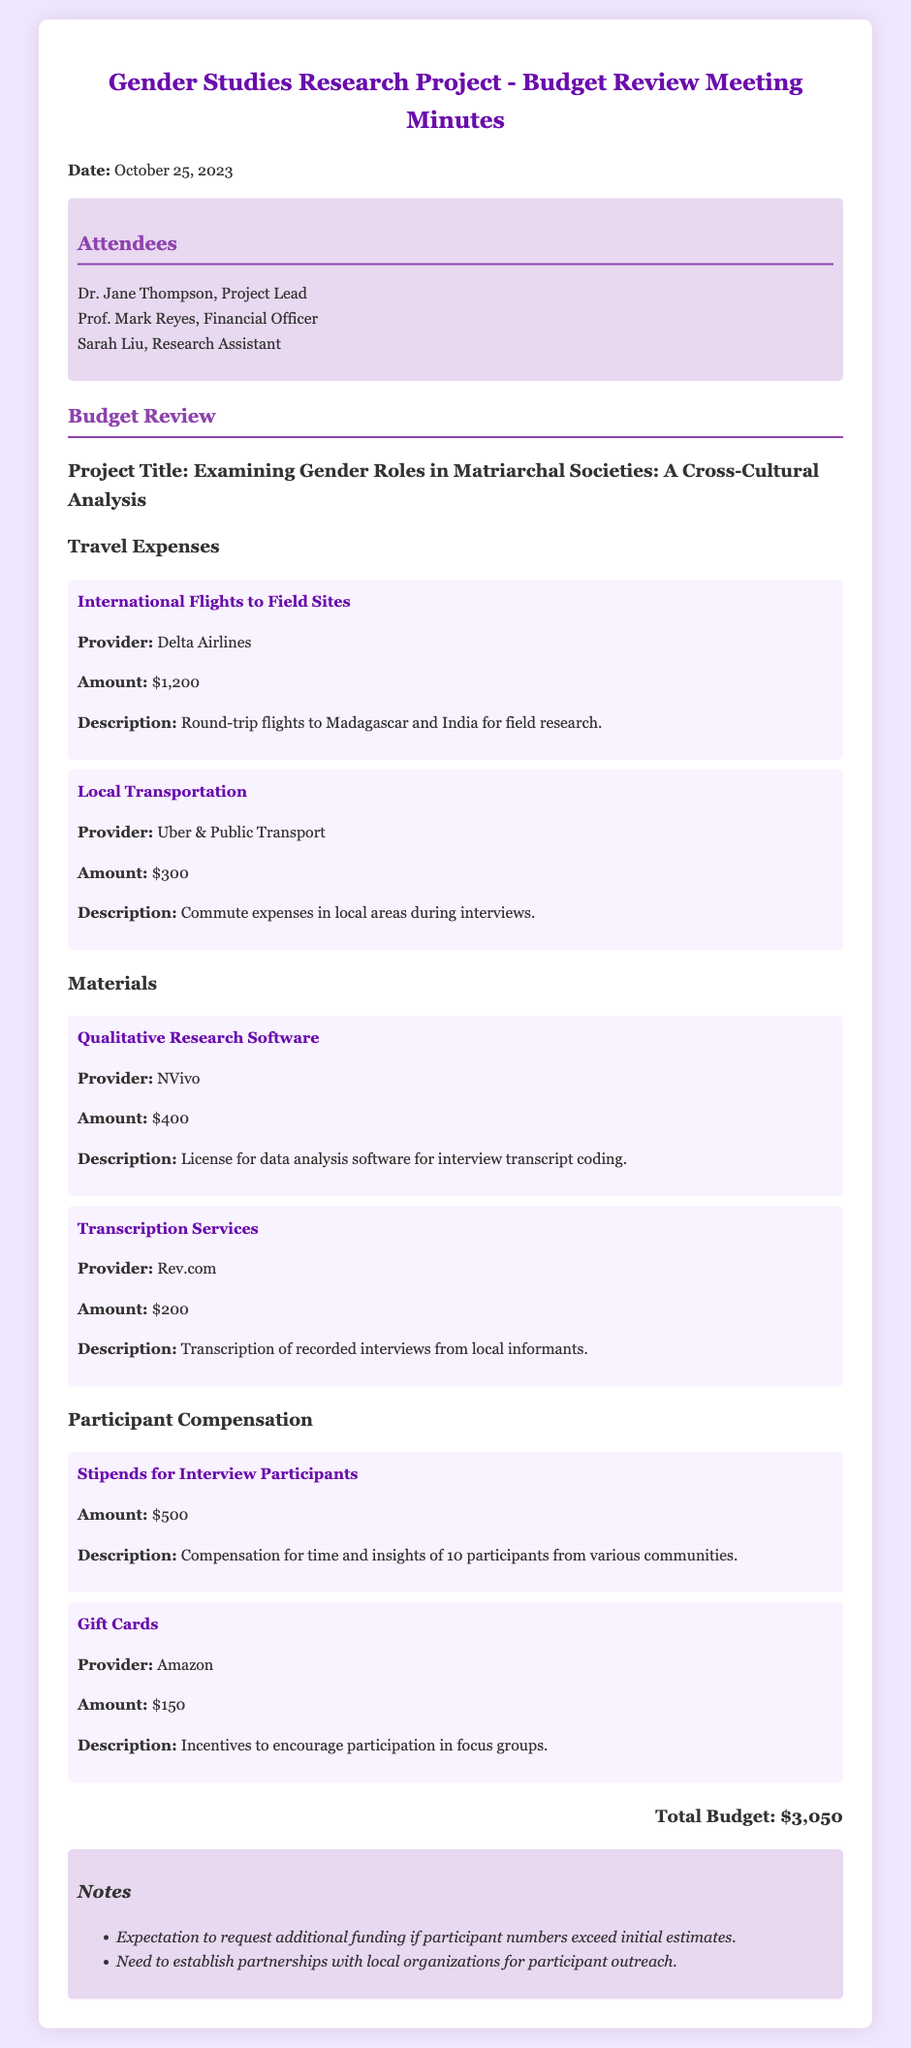What is the date of the meeting? The date of the meeting is explicitly mentioned in the document as October 25, 2023.
Answer: October 25, 2023 Who is the Project Lead? The document lists Dr. Jane Thompson as the Project Lead among the attendees.
Answer: Dr. Jane Thompson What is the amount budgeted for international flights? The budget for international flights is specified as $1,200, which is detailed in the travel expenses section.
Answer: $1,200 How much is allocated for participant stipends? The document states that $500 is allocated for stipends to compensate interview participants.
Answer: $500 What is the total budget for the project? The total budget is calculated and displayed in the document as the sum of all expenses, which totals to $3,050.
Answer: $3,050 What is the provider for the qualitative research software? The document identifies NVivo as the provider for the qualitative research software.
Answer: NVivo Why might additional funding be requested? The document notes a potential need for additional funding if participant numbers exceed initial estimates.
Answer: Participant numbers exceed initial estimates What type of document is this? The nature of this document is identified as meeting minutes for a budget review.
Answer: Meeting minutes What amount is budgeted for gift cards? The document specifies that $150 is budgeted for gift cards as incentives for participation in focus groups.
Answer: $150 